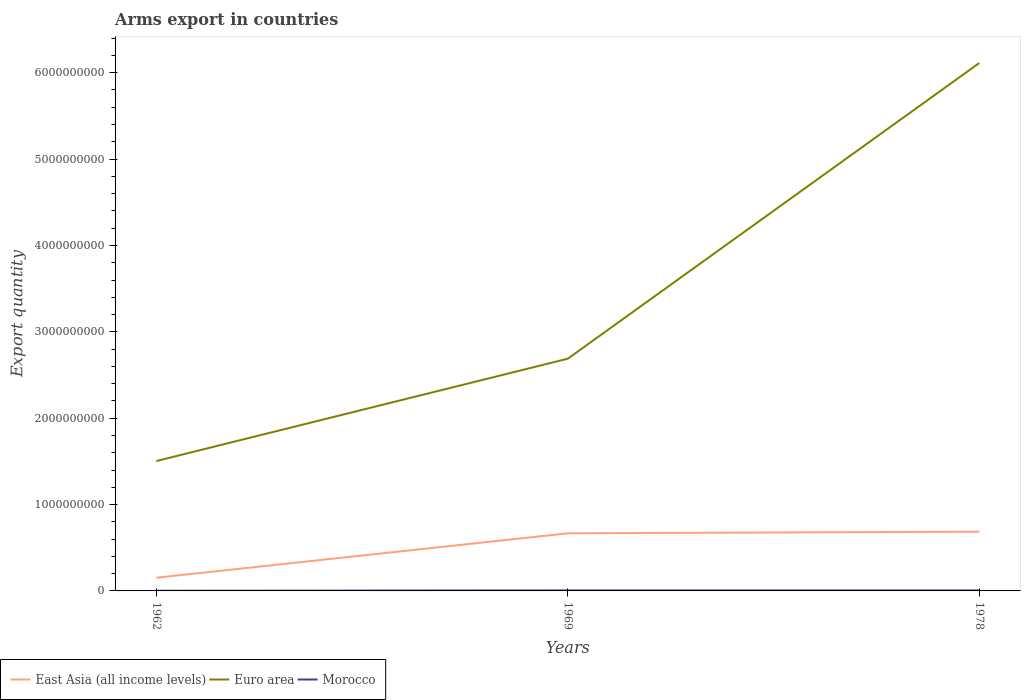How many different coloured lines are there?
Provide a succinct answer. 3. Is the number of lines equal to the number of legend labels?
Give a very brief answer. Yes. In which year was the total arms export in East Asia (all income levels) maximum?
Provide a succinct answer. 1962. What is the total total arms export in Euro area in the graph?
Offer a very short reply. -4.61e+09. What is the difference between the highest and the second highest total arms export in East Asia (all income levels)?
Provide a succinct answer. 5.33e+08. Is the total arms export in Euro area strictly greater than the total arms export in Morocco over the years?
Offer a terse response. No. How many lines are there?
Give a very brief answer. 3. What is the difference between two consecutive major ticks on the Y-axis?
Make the answer very short. 1.00e+09. Does the graph contain any zero values?
Offer a terse response. No. Does the graph contain grids?
Ensure brevity in your answer.  No. How many legend labels are there?
Your answer should be compact. 3. What is the title of the graph?
Keep it short and to the point. Arms export in countries. What is the label or title of the X-axis?
Ensure brevity in your answer.  Years. What is the label or title of the Y-axis?
Make the answer very short. Export quantity. What is the Export quantity in East Asia (all income levels) in 1962?
Provide a succinct answer. 1.53e+08. What is the Export quantity in Euro area in 1962?
Your answer should be compact. 1.50e+09. What is the Export quantity in East Asia (all income levels) in 1969?
Offer a terse response. 6.67e+08. What is the Export quantity in Euro area in 1969?
Your answer should be very brief. 2.69e+09. What is the Export quantity in East Asia (all income levels) in 1978?
Provide a succinct answer. 6.86e+08. What is the Export quantity in Euro area in 1978?
Ensure brevity in your answer.  6.11e+09. Across all years, what is the maximum Export quantity in East Asia (all income levels)?
Keep it short and to the point. 6.86e+08. Across all years, what is the maximum Export quantity in Euro area?
Your answer should be very brief. 6.11e+09. Across all years, what is the minimum Export quantity in East Asia (all income levels)?
Ensure brevity in your answer.  1.53e+08. Across all years, what is the minimum Export quantity in Euro area?
Provide a succinct answer. 1.50e+09. Across all years, what is the minimum Export quantity in Morocco?
Your response must be concise. 2.00e+06. What is the total Export quantity of East Asia (all income levels) in the graph?
Make the answer very short. 1.51e+09. What is the total Export quantity of Euro area in the graph?
Make the answer very short. 1.03e+1. What is the total Export quantity of Morocco in the graph?
Provide a succinct answer. 1.40e+07. What is the difference between the Export quantity of East Asia (all income levels) in 1962 and that in 1969?
Provide a short and direct response. -5.14e+08. What is the difference between the Export quantity in Euro area in 1962 and that in 1969?
Provide a short and direct response. -1.18e+09. What is the difference between the Export quantity in East Asia (all income levels) in 1962 and that in 1978?
Provide a succinct answer. -5.33e+08. What is the difference between the Export quantity in Euro area in 1962 and that in 1978?
Keep it short and to the point. -4.61e+09. What is the difference between the Export quantity of East Asia (all income levels) in 1969 and that in 1978?
Give a very brief answer. -1.90e+07. What is the difference between the Export quantity in Euro area in 1969 and that in 1978?
Your answer should be compact. -3.42e+09. What is the difference between the Export quantity in East Asia (all income levels) in 1962 and the Export quantity in Euro area in 1969?
Keep it short and to the point. -2.54e+09. What is the difference between the Export quantity of East Asia (all income levels) in 1962 and the Export quantity of Morocco in 1969?
Provide a succinct answer. 1.47e+08. What is the difference between the Export quantity in Euro area in 1962 and the Export quantity in Morocco in 1969?
Provide a short and direct response. 1.50e+09. What is the difference between the Export quantity of East Asia (all income levels) in 1962 and the Export quantity of Euro area in 1978?
Your answer should be very brief. -5.96e+09. What is the difference between the Export quantity of East Asia (all income levels) in 1962 and the Export quantity of Morocco in 1978?
Your response must be concise. 1.47e+08. What is the difference between the Export quantity of Euro area in 1962 and the Export quantity of Morocco in 1978?
Make the answer very short. 1.50e+09. What is the difference between the Export quantity of East Asia (all income levels) in 1969 and the Export quantity of Euro area in 1978?
Provide a short and direct response. -5.45e+09. What is the difference between the Export quantity of East Asia (all income levels) in 1969 and the Export quantity of Morocco in 1978?
Your answer should be compact. 6.61e+08. What is the difference between the Export quantity of Euro area in 1969 and the Export quantity of Morocco in 1978?
Offer a very short reply. 2.68e+09. What is the average Export quantity in East Asia (all income levels) per year?
Offer a very short reply. 5.02e+08. What is the average Export quantity in Euro area per year?
Keep it short and to the point. 3.44e+09. What is the average Export quantity in Morocco per year?
Provide a short and direct response. 4.67e+06. In the year 1962, what is the difference between the Export quantity in East Asia (all income levels) and Export quantity in Euro area?
Keep it short and to the point. -1.35e+09. In the year 1962, what is the difference between the Export quantity in East Asia (all income levels) and Export quantity in Morocco?
Your response must be concise. 1.51e+08. In the year 1962, what is the difference between the Export quantity in Euro area and Export quantity in Morocco?
Your response must be concise. 1.50e+09. In the year 1969, what is the difference between the Export quantity of East Asia (all income levels) and Export quantity of Euro area?
Your answer should be compact. -2.02e+09. In the year 1969, what is the difference between the Export quantity in East Asia (all income levels) and Export quantity in Morocco?
Ensure brevity in your answer.  6.61e+08. In the year 1969, what is the difference between the Export quantity of Euro area and Export quantity of Morocco?
Your answer should be compact. 2.68e+09. In the year 1978, what is the difference between the Export quantity of East Asia (all income levels) and Export quantity of Euro area?
Keep it short and to the point. -5.43e+09. In the year 1978, what is the difference between the Export quantity of East Asia (all income levels) and Export quantity of Morocco?
Give a very brief answer. 6.80e+08. In the year 1978, what is the difference between the Export quantity of Euro area and Export quantity of Morocco?
Your answer should be compact. 6.11e+09. What is the ratio of the Export quantity in East Asia (all income levels) in 1962 to that in 1969?
Offer a very short reply. 0.23. What is the ratio of the Export quantity of Euro area in 1962 to that in 1969?
Your answer should be compact. 0.56. What is the ratio of the Export quantity of Morocco in 1962 to that in 1969?
Your response must be concise. 0.33. What is the ratio of the Export quantity in East Asia (all income levels) in 1962 to that in 1978?
Your response must be concise. 0.22. What is the ratio of the Export quantity in Euro area in 1962 to that in 1978?
Keep it short and to the point. 0.25. What is the ratio of the Export quantity in Morocco in 1962 to that in 1978?
Ensure brevity in your answer.  0.33. What is the ratio of the Export quantity of East Asia (all income levels) in 1969 to that in 1978?
Your answer should be compact. 0.97. What is the ratio of the Export quantity in Euro area in 1969 to that in 1978?
Give a very brief answer. 0.44. What is the ratio of the Export quantity of Morocco in 1969 to that in 1978?
Your response must be concise. 1. What is the difference between the highest and the second highest Export quantity of East Asia (all income levels)?
Provide a succinct answer. 1.90e+07. What is the difference between the highest and the second highest Export quantity in Euro area?
Give a very brief answer. 3.42e+09. What is the difference between the highest and the lowest Export quantity in East Asia (all income levels)?
Your answer should be compact. 5.33e+08. What is the difference between the highest and the lowest Export quantity of Euro area?
Ensure brevity in your answer.  4.61e+09. 